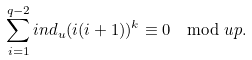<formula> <loc_0><loc_0><loc_500><loc_500>\sum _ { i = 1 } ^ { q - 2 } i n d _ { u } ( i ( i + 1 ) ) ^ { k } \equiv 0 \mod u p .</formula> 